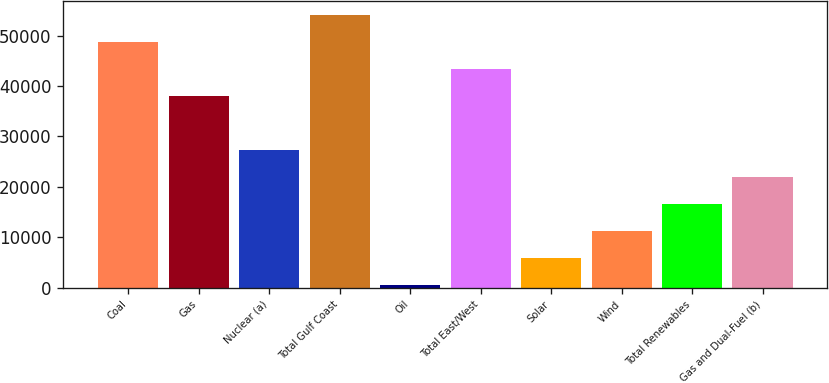<chart> <loc_0><loc_0><loc_500><loc_500><bar_chart><fcel>Coal<fcel>Gas<fcel>Nuclear (a)<fcel>Total Gulf Coast<fcel>Oil<fcel>Total East/West<fcel>Solar<fcel>Wind<fcel>Total Renewables<fcel>Gas and Dual-Fuel (b)<nl><fcel>48802.5<fcel>38083.5<fcel>27364.5<fcel>54162<fcel>567<fcel>43443<fcel>5926.5<fcel>11286<fcel>16645.5<fcel>22005<nl></chart> 